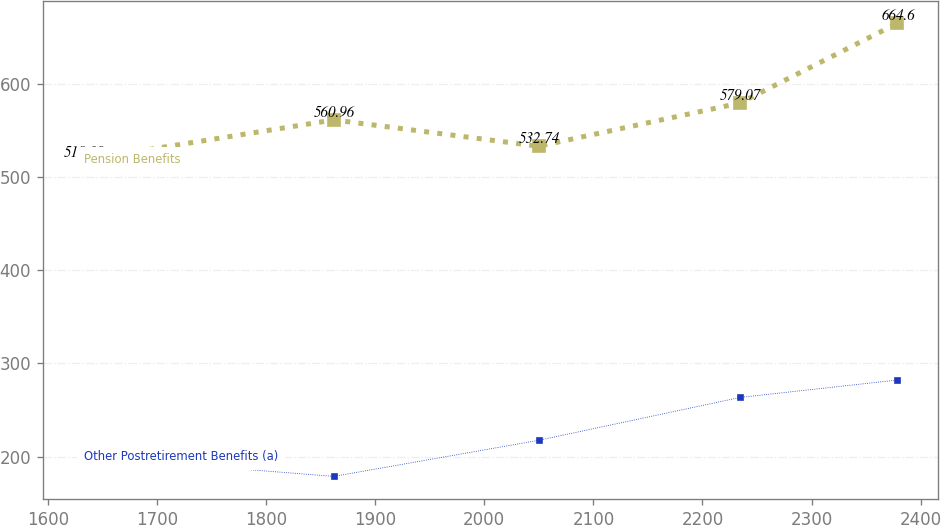Convert chart to OTSL. <chart><loc_0><loc_0><loc_500><loc_500><line_chart><ecel><fcel>Pension Benefits<fcel>Other Postretirement Benefits (a)<nl><fcel>1632.62<fcel>518.09<fcel>199.96<nl><fcel>1862.02<fcel>560.96<fcel>178.67<nl><fcel>2049.74<fcel>532.74<fcel>217.34<nl><fcel>2234.33<fcel>579.07<fcel>263.31<nl><fcel>2378.68<fcel>664.6<fcel>282.01<nl></chart> 